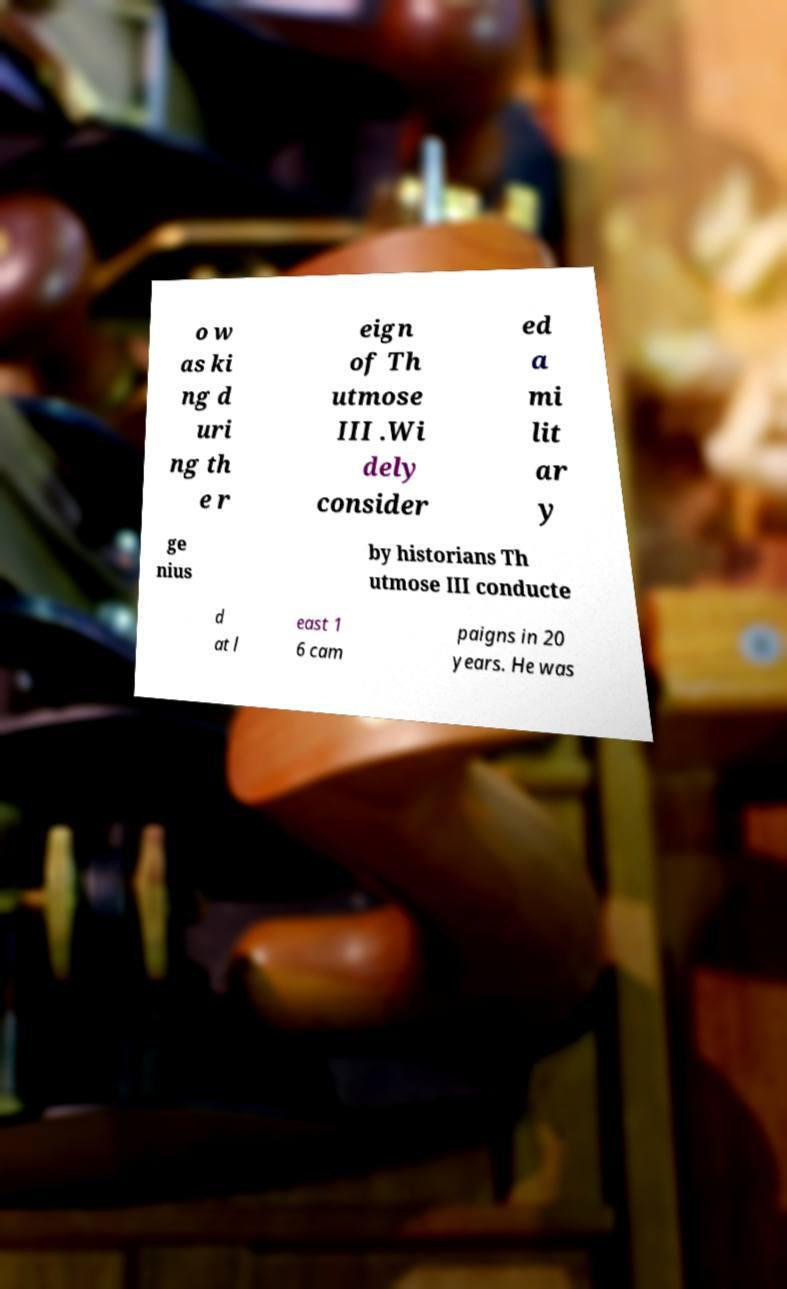Can you accurately transcribe the text from the provided image for me? o w as ki ng d uri ng th e r eign of Th utmose III .Wi dely consider ed a mi lit ar y ge nius by historians Th utmose III conducte d at l east 1 6 cam paigns in 20 years. He was 